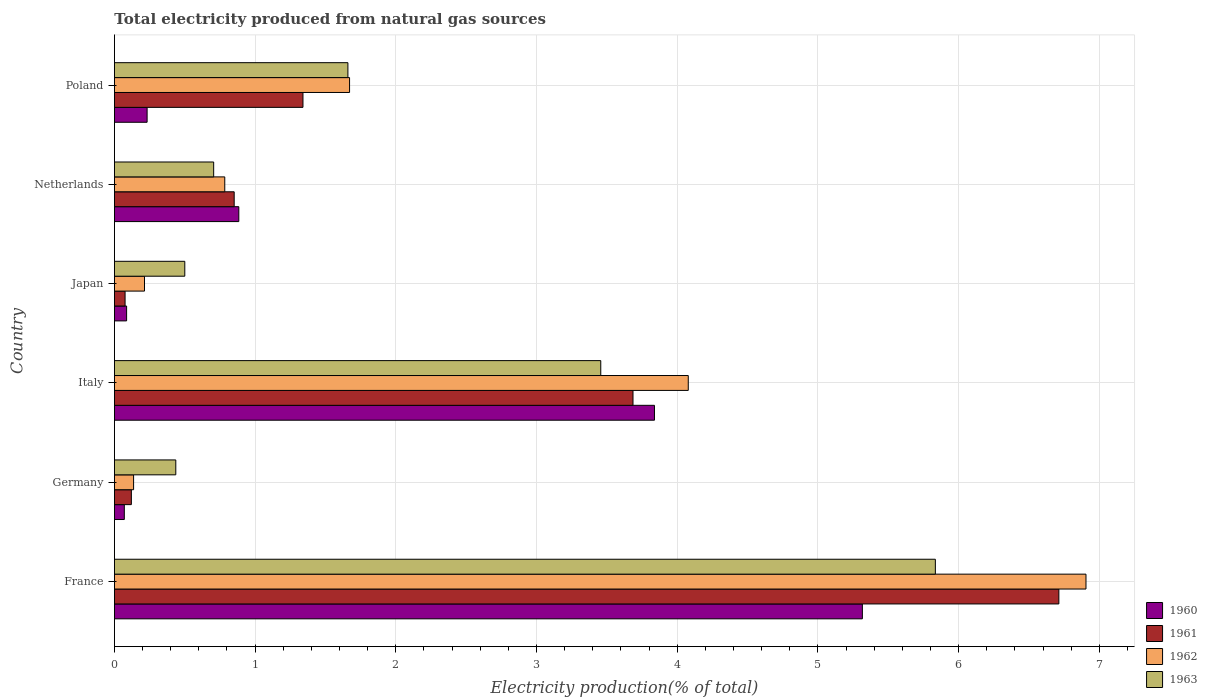How many groups of bars are there?
Offer a terse response. 6. Are the number of bars per tick equal to the number of legend labels?
Ensure brevity in your answer.  Yes. Are the number of bars on each tick of the Y-axis equal?
Make the answer very short. Yes. How many bars are there on the 2nd tick from the top?
Provide a short and direct response. 4. What is the total electricity produced in 1963 in Germany?
Offer a terse response. 0.44. Across all countries, what is the maximum total electricity produced in 1961?
Offer a terse response. 6.71. Across all countries, what is the minimum total electricity produced in 1961?
Offer a terse response. 0.08. In which country was the total electricity produced in 1962 minimum?
Your answer should be very brief. Germany. What is the total total electricity produced in 1963 in the graph?
Your answer should be compact. 12.59. What is the difference between the total electricity produced in 1962 in Italy and that in Netherlands?
Your answer should be compact. 3.29. What is the difference between the total electricity produced in 1963 in France and the total electricity produced in 1961 in Netherlands?
Provide a short and direct response. 4.98. What is the average total electricity produced in 1960 per country?
Your response must be concise. 1.74. What is the difference between the total electricity produced in 1963 and total electricity produced in 1962 in France?
Give a very brief answer. -1.07. In how many countries, is the total electricity produced in 1962 greater than 5.4 %?
Make the answer very short. 1. What is the ratio of the total electricity produced in 1961 in France to that in Poland?
Your response must be concise. 5.01. What is the difference between the highest and the second highest total electricity produced in 1963?
Provide a short and direct response. 2.38. What is the difference between the highest and the lowest total electricity produced in 1961?
Provide a short and direct response. 6.64. In how many countries, is the total electricity produced in 1961 greater than the average total electricity produced in 1961 taken over all countries?
Your answer should be very brief. 2. Is it the case that in every country, the sum of the total electricity produced in 1962 and total electricity produced in 1961 is greater than the total electricity produced in 1963?
Your response must be concise. No. Are all the bars in the graph horizontal?
Ensure brevity in your answer.  Yes. How many countries are there in the graph?
Provide a short and direct response. 6. Are the values on the major ticks of X-axis written in scientific E-notation?
Keep it short and to the point. No. Does the graph contain grids?
Keep it short and to the point. Yes. What is the title of the graph?
Offer a terse response. Total electricity produced from natural gas sources. What is the label or title of the X-axis?
Offer a terse response. Electricity production(% of total). What is the label or title of the Y-axis?
Make the answer very short. Country. What is the Electricity production(% of total) of 1960 in France?
Provide a succinct answer. 5.32. What is the Electricity production(% of total) of 1961 in France?
Your answer should be very brief. 6.71. What is the Electricity production(% of total) in 1962 in France?
Provide a short and direct response. 6.91. What is the Electricity production(% of total) in 1963 in France?
Your answer should be compact. 5.83. What is the Electricity production(% of total) in 1960 in Germany?
Ensure brevity in your answer.  0.07. What is the Electricity production(% of total) of 1961 in Germany?
Your response must be concise. 0.12. What is the Electricity production(% of total) in 1962 in Germany?
Your response must be concise. 0.14. What is the Electricity production(% of total) of 1963 in Germany?
Offer a very short reply. 0.44. What is the Electricity production(% of total) in 1960 in Italy?
Provide a succinct answer. 3.84. What is the Electricity production(% of total) in 1961 in Italy?
Offer a very short reply. 3.69. What is the Electricity production(% of total) in 1962 in Italy?
Offer a terse response. 4.08. What is the Electricity production(% of total) of 1963 in Italy?
Provide a short and direct response. 3.46. What is the Electricity production(% of total) of 1960 in Japan?
Provide a short and direct response. 0.09. What is the Electricity production(% of total) of 1961 in Japan?
Give a very brief answer. 0.08. What is the Electricity production(% of total) in 1962 in Japan?
Make the answer very short. 0.21. What is the Electricity production(% of total) in 1963 in Japan?
Provide a succinct answer. 0.5. What is the Electricity production(% of total) of 1960 in Netherlands?
Keep it short and to the point. 0.88. What is the Electricity production(% of total) of 1961 in Netherlands?
Ensure brevity in your answer.  0.85. What is the Electricity production(% of total) of 1962 in Netherlands?
Make the answer very short. 0.78. What is the Electricity production(% of total) in 1963 in Netherlands?
Your response must be concise. 0.71. What is the Electricity production(% of total) of 1960 in Poland?
Keep it short and to the point. 0.23. What is the Electricity production(% of total) of 1961 in Poland?
Keep it short and to the point. 1.34. What is the Electricity production(% of total) of 1962 in Poland?
Give a very brief answer. 1.67. What is the Electricity production(% of total) of 1963 in Poland?
Offer a terse response. 1.66. Across all countries, what is the maximum Electricity production(% of total) in 1960?
Offer a terse response. 5.32. Across all countries, what is the maximum Electricity production(% of total) in 1961?
Your answer should be compact. 6.71. Across all countries, what is the maximum Electricity production(% of total) in 1962?
Keep it short and to the point. 6.91. Across all countries, what is the maximum Electricity production(% of total) of 1963?
Offer a very short reply. 5.83. Across all countries, what is the minimum Electricity production(% of total) of 1960?
Your response must be concise. 0.07. Across all countries, what is the minimum Electricity production(% of total) of 1961?
Provide a succinct answer. 0.08. Across all countries, what is the minimum Electricity production(% of total) of 1962?
Ensure brevity in your answer.  0.14. Across all countries, what is the minimum Electricity production(% of total) of 1963?
Provide a short and direct response. 0.44. What is the total Electricity production(% of total) in 1960 in the graph?
Ensure brevity in your answer.  10.43. What is the total Electricity production(% of total) of 1961 in the graph?
Your response must be concise. 12.79. What is the total Electricity production(% of total) of 1962 in the graph?
Provide a short and direct response. 13.79. What is the total Electricity production(% of total) in 1963 in the graph?
Give a very brief answer. 12.59. What is the difference between the Electricity production(% of total) in 1960 in France and that in Germany?
Provide a succinct answer. 5.25. What is the difference between the Electricity production(% of total) in 1961 in France and that in Germany?
Your answer should be compact. 6.59. What is the difference between the Electricity production(% of total) of 1962 in France and that in Germany?
Offer a terse response. 6.77. What is the difference between the Electricity production(% of total) of 1963 in France and that in Germany?
Give a very brief answer. 5.4. What is the difference between the Electricity production(% of total) of 1960 in France and that in Italy?
Provide a short and direct response. 1.48. What is the difference between the Electricity production(% of total) in 1961 in France and that in Italy?
Make the answer very short. 3.03. What is the difference between the Electricity production(% of total) of 1962 in France and that in Italy?
Provide a short and direct response. 2.83. What is the difference between the Electricity production(% of total) of 1963 in France and that in Italy?
Your response must be concise. 2.38. What is the difference between the Electricity production(% of total) of 1960 in France and that in Japan?
Keep it short and to the point. 5.23. What is the difference between the Electricity production(% of total) of 1961 in France and that in Japan?
Your response must be concise. 6.64. What is the difference between the Electricity production(% of total) of 1962 in France and that in Japan?
Your answer should be compact. 6.69. What is the difference between the Electricity production(% of total) of 1963 in France and that in Japan?
Give a very brief answer. 5.33. What is the difference between the Electricity production(% of total) of 1960 in France and that in Netherlands?
Make the answer very short. 4.43. What is the difference between the Electricity production(% of total) of 1961 in France and that in Netherlands?
Ensure brevity in your answer.  5.86. What is the difference between the Electricity production(% of total) of 1962 in France and that in Netherlands?
Provide a succinct answer. 6.12. What is the difference between the Electricity production(% of total) of 1963 in France and that in Netherlands?
Provide a succinct answer. 5.13. What is the difference between the Electricity production(% of total) in 1960 in France and that in Poland?
Ensure brevity in your answer.  5.08. What is the difference between the Electricity production(% of total) in 1961 in France and that in Poland?
Offer a terse response. 5.37. What is the difference between the Electricity production(% of total) in 1962 in France and that in Poland?
Your response must be concise. 5.23. What is the difference between the Electricity production(% of total) in 1963 in France and that in Poland?
Your answer should be compact. 4.18. What is the difference between the Electricity production(% of total) in 1960 in Germany and that in Italy?
Provide a succinct answer. -3.77. What is the difference between the Electricity production(% of total) of 1961 in Germany and that in Italy?
Ensure brevity in your answer.  -3.57. What is the difference between the Electricity production(% of total) in 1962 in Germany and that in Italy?
Your response must be concise. -3.94. What is the difference between the Electricity production(% of total) in 1963 in Germany and that in Italy?
Your answer should be compact. -3.02. What is the difference between the Electricity production(% of total) of 1960 in Germany and that in Japan?
Ensure brevity in your answer.  -0.02. What is the difference between the Electricity production(% of total) in 1961 in Germany and that in Japan?
Your answer should be very brief. 0.04. What is the difference between the Electricity production(% of total) in 1962 in Germany and that in Japan?
Make the answer very short. -0.08. What is the difference between the Electricity production(% of total) of 1963 in Germany and that in Japan?
Ensure brevity in your answer.  -0.06. What is the difference between the Electricity production(% of total) of 1960 in Germany and that in Netherlands?
Your response must be concise. -0.81. What is the difference between the Electricity production(% of total) in 1961 in Germany and that in Netherlands?
Your answer should be very brief. -0.73. What is the difference between the Electricity production(% of total) in 1962 in Germany and that in Netherlands?
Ensure brevity in your answer.  -0.65. What is the difference between the Electricity production(% of total) of 1963 in Germany and that in Netherlands?
Your response must be concise. -0.27. What is the difference between the Electricity production(% of total) in 1960 in Germany and that in Poland?
Provide a succinct answer. -0.16. What is the difference between the Electricity production(% of total) in 1961 in Germany and that in Poland?
Provide a succinct answer. -1.22. What is the difference between the Electricity production(% of total) of 1962 in Germany and that in Poland?
Your response must be concise. -1.53. What is the difference between the Electricity production(% of total) of 1963 in Germany and that in Poland?
Your response must be concise. -1.22. What is the difference between the Electricity production(% of total) in 1960 in Italy and that in Japan?
Your answer should be compact. 3.75. What is the difference between the Electricity production(% of total) in 1961 in Italy and that in Japan?
Offer a terse response. 3.61. What is the difference between the Electricity production(% of total) in 1962 in Italy and that in Japan?
Provide a succinct answer. 3.86. What is the difference between the Electricity production(% of total) of 1963 in Italy and that in Japan?
Make the answer very short. 2.96. What is the difference between the Electricity production(% of total) of 1960 in Italy and that in Netherlands?
Your response must be concise. 2.95. What is the difference between the Electricity production(% of total) of 1961 in Italy and that in Netherlands?
Provide a succinct answer. 2.83. What is the difference between the Electricity production(% of total) of 1962 in Italy and that in Netherlands?
Ensure brevity in your answer.  3.29. What is the difference between the Electricity production(% of total) in 1963 in Italy and that in Netherlands?
Offer a very short reply. 2.75. What is the difference between the Electricity production(% of total) of 1960 in Italy and that in Poland?
Your answer should be very brief. 3.61. What is the difference between the Electricity production(% of total) in 1961 in Italy and that in Poland?
Make the answer very short. 2.35. What is the difference between the Electricity production(% of total) of 1962 in Italy and that in Poland?
Your answer should be compact. 2.41. What is the difference between the Electricity production(% of total) of 1963 in Italy and that in Poland?
Ensure brevity in your answer.  1.8. What is the difference between the Electricity production(% of total) of 1960 in Japan and that in Netherlands?
Provide a succinct answer. -0.8. What is the difference between the Electricity production(% of total) of 1961 in Japan and that in Netherlands?
Provide a succinct answer. -0.78. What is the difference between the Electricity production(% of total) of 1962 in Japan and that in Netherlands?
Your answer should be very brief. -0.57. What is the difference between the Electricity production(% of total) in 1963 in Japan and that in Netherlands?
Offer a very short reply. -0.21. What is the difference between the Electricity production(% of total) in 1960 in Japan and that in Poland?
Your response must be concise. -0.15. What is the difference between the Electricity production(% of total) in 1961 in Japan and that in Poland?
Your response must be concise. -1.26. What is the difference between the Electricity production(% of total) in 1962 in Japan and that in Poland?
Your answer should be compact. -1.46. What is the difference between the Electricity production(% of total) of 1963 in Japan and that in Poland?
Provide a short and direct response. -1.16. What is the difference between the Electricity production(% of total) in 1960 in Netherlands and that in Poland?
Keep it short and to the point. 0.65. What is the difference between the Electricity production(% of total) of 1961 in Netherlands and that in Poland?
Keep it short and to the point. -0.49. What is the difference between the Electricity production(% of total) of 1962 in Netherlands and that in Poland?
Your answer should be very brief. -0.89. What is the difference between the Electricity production(% of total) in 1963 in Netherlands and that in Poland?
Your response must be concise. -0.95. What is the difference between the Electricity production(% of total) in 1960 in France and the Electricity production(% of total) in 1961 in Germany?
Keep it short and to the point. 5.2. What is the difference between the Electricity production(% of total) of 1960 in France and the Electricity production(% of total) of 1962 in Germany?
Keep it short and to the point. 5.18. What is the difference between the Electricity production(% of total) in 1960 in France and the Electricity production(% of total) in 1963 in Germany?
Provide a succinct answer. 4.88. What is the difference between the Electricity production(% of total) of 1961 in France and the Electricity production(% of total) of 1962 in Germany?
Make the answer very short. 6.58. What is the difference between the Electricity production(% of total) of 1961 in France and the Electricity production(% of total) of 1963 in Germany?
Give a very brief answer. 6.28. What is the difference between the Electricity production(% of total) of 1962 in France and the Electricity production(% of total) of 1963 in Germany?
Provide a short and direct response. 6.47. What is the difference between the Electricity production(% of total) of 1960 in France and the Electricity production(% of total) of 1961 in Italy?
Your answer should be very brief. 1.63. What is the difference between the Electricity production(% of total) of 1960 in France and the Electricity production(% of total) of 1962 in Italy?
Provide a short and direct response. 1.24. What is the difference between the Electricity production(% of total) in 1960 in France and the Electricity production(% of total) in 1963 in Italy?
Your response must be concise. 1.86. What is the difference between the Electricity production(% of total) in 1961 in France and the Electricity production(% of total) in 1962 in Italy?
Offer a very short reply. 2.63. What is the difference between the Electricity production(% of total) of 1961 in France and the Electricity production(% of total) of 1963 in Italy?
Give a very brief answer. 3.26. What is the difference between the Electricity production(% of total) of 1962 in France and the Electricity production(% of total) of 1963 in Italy?
Your answer should be compact. 3.45. What is the difference between the Electricity production(% of total) of 1960 in France and the Electricity production(% of total) of 1961 in Japan?
Your answer should be compact. 5.24. What is the difference between the Electricity production(% of total) in 1960 in France and the Electricity production(% of total) in 1962 in Japan?
Make the answer very short. 5.1. What is the difference between the Electricity production(% of total) in 1960 in France and the Electricity production(% of total) in 1963 in Japan?
Your response must be concise. 4.82. What is the difference between the Electricity production(% of total) in 1961 in France and the Electricity production(% of total) in 1962 in Japan?
Keep it short and to the point. 6.5. What is the difference between the Electricity production(% of total) in 1961 in France and the Electricity production(% of total) in 1963 in Japan?
Your response must be concise. 6.21. What is the difference between the Electricity production(% of total) in 1962 in France and the Electricity production(% of total) in 1963 in Japan?
Your response must be concise. 6.4. What is the difference between the Electricity production(% of total) of 1960 in France and the Electricity production(% of total) of 1961 in Netherlands?
Ensure brevity in your answer.  4.46. What is the difference between the Electricity production(% of total) in 1960 in France and the Electricity production(% of total) in 1962 in Netherlands?
Provide a short and direct response. 4.53. What is the difference between the Electricity production(% of total) in 1960 in France and the Electricity production(% of total) in 1963 in Netherlands?
Give a very brief answer. 4.61. What is the difference between the Electricity production(% of total) in 1961 in France and the Electricity production(% of total) in 1962 in Netherlands?
Offer a terse response. 5.93. What is the difference between the Electricity production(% of total) of 1961 in France and the Electricity production(% of total) of 1963 in Netherlands?
Your answer should be very brief. 6.01. What is the difference between the Electricity production(% of total) in 1962 in France and the Electricity production(% of total) in 1963 in Netherlands?
Your response must be concise. 6.2. What is the difference between the Electricity production(% of total) of 1960 in France and the Electricity production(% of total) of 1961 in Poland?
Make the answer very short. 3.98. What is the difference between the Electricity production(% of total) in 1960 in France and the Electricity production(% of total) in 1962 in Poland?
Keep it short and to the point. 3.64. What is the difference between the Electricity production(% of total) in 1960 in France and the Electricity production(% of total) in 1963 in Poland?
Ensure brevity in your answer.  3.66. What is the difference between the Electricity production(% of total) of 1961 in France and the Electricity production(% of total) of 1962 in Poland?
Your answer should be compact. 5.04. What is the difference between the Electricity production(% of total) of 1961 in France and the Electricity production(% of total) of 1963 in Poland?
Keep it short and to the point. 5.05. What is the difference between the Electricity production(% of total) of 1962 in France and the Electricity production(% of total) of 1963 in Poland?
Your answer should be compact. 5.25. What is the difference between the Electricity production(% of total) in 1960 in Germany and the Electricity production(% of total) in 1961 in Italy?
Your response must be concise. -3.62. What is the difference between the Electricity production(% of total) of 1960 in Germany and the Electricity production(% of total) of 1962 in Italy?
Your answer should be compact. -4.01. What is the difference between the Electricity production(% of total) in 1960 in Germany and the Electricity production(% of total) in 1963 in Italy?
Your answer should be very brief. -3.39. What is the difference between the Electricity production(% of total) in 1961 in Germany and the Electricity production(% of total) in 1962 in Italy?
Your answer should be compact. -3.96. What is the difference between the Electricity production(% of total) of 1961 in Germany and the Electricity production(% of total) of 1963 in Italy?
Make the answer very short. -3.34. What is the difference between the Electricity production(% of total) in 1962 in Germany and the Electricity production(% of total) in 1963 in Italy?
Offer a terse response. -3.32. What is the difference between the Electricity production(% of total) in 1960 in Germany and the Electricity production(% of total) in 1961 in Japan?
Give a very brief answer. -0.01. What is the difference between the Electricity production(% of total) of 1960 in Germany and the Electricity production(% of total) of 1962 in Japan?
Offer a terse response. -0.14. What is the difference between the Electricity production(% of total) of 1960 in Germany and the Electricity production(% of total) of 1963 in Japan?
Keep it short and to the point. -0.43. What is the difference between the Electricity production(% of total) in 1961 in Germany and the Electricity production(% of total) in 1962 in Japan?
Keep it short and to the point. -0.09. What is the difference between the Electricity production(% of total) in 1961 in Germany and the Electricity production(% of total) in 1963 in Japan?
Your response must be concise. -0.38. What is the difference between the Electricity production(% of total) in 1962 in Germany and the Electricity production(% of total) in 1963 in Japan?
Your answer should be very brief. -0.36. What is the difference between the Electricity production(% of total) of 1960 in Germany and the Electricity production(% of total) of 1961 in Netherlands?
Your response must be concise. -0.78. What is the difference between the Electricity production(% of total) in 1960 in Germany and the Electricity production(% of total) in 1962 in Netherlands?
Offer a terse response. -0.71. What is the difference between the Electricity production(% of total) of 1960 in Germany and the Electricity production(% of total) of 1963 in Netherlands?
Keep it short and to the point. -0.64. What is the difference between the Electricity production(% of total) of 1961 in Germany and the Electricity production(% of total) of 1962 in Netherlands?
Keep it short and to the point. -0.66. What is the difference between the Electricity production(% of total) of 1961 in Germany and the Electricity production(% of total) of 1963 in Netherlands?
Ensure brevity in your answer.  -0.58. What is the difference between the Electricity production(% of total) of 1962 in Germany and the Electricity production(% of total) of 1963 in Netherlands?
Keep it short and to the point. -0.57. What is the difference between the Electricity production(% of total) of 1960 in Germany and the Electricity production(% of total) of 1961 in Poland?
Ensure brevity in your answer.  -1.27. What is the difference between the Electricity production(% of total) of 1960 in Germany and the Electricity production(% of total) of 1962 in Poland?
Your answer should be very brief. -1.6. What is the difference between the Electricity production(% of total) in 1960 in Germany and the Electricity production(% of total) in 1963 in Poland?
Offer a terse response. -1.59. What is the difference between the Electricity production(% of total) of 1961 in Germany and the Electricity production(% of total) of 1962 in Poland?
Ensure brevity in your answer.  -1.55. What is the difference between the Electricity production(% of total) of 1961 in Germany and the Electricity production(% of total) of 1963 in Poland?
Your answer should be compact. -1.54. What is the difference between the Electricity production(% of total) of 1962 in Germany and the Electricity production(% of total) of 1963 in Poland?
Offer a terse response. -1.52. What is the difference between the Electricity production(% of total) of 1960 in Italy and the Electricity production(% of total) of 1961 in Japan?
Make the answer very short. 3.76. What is the difference between the Electricity production(% of total) of 1960 in Italy and the Electricity production(% of total) of 1962 in Japan?
Your answer should be very brief. 3.62. What is the difference between the Electricity production(% of total) of 1960 in Italy and the Electricity production(% of total) of 1963 in Japan?
Offer a very short reply. 3.34. What is the difference between the Electricity production(% of total) in 1961 in Italy and the Electricity production(% of total) in 1962 in Japan?
Provide a succinct answer. 3.47. What is the difference between the Electricity production(% of total) in 1961 in Italy and the Electricity production(% of total) in 1963 in Japan?
Ensure brevity in your answer.  3.19. What is the difference between the Electricity production(% of total) of 1962 in Italy and the Electricity production(% of total) of 1963 in Japan?
Offer a very short reply. 3.58. What is the difference between the Electricity production(% of total) in 1960 in Italy and the Electricity production(% of total) in 1961 in Netherlands?
Keep it short and to the point. 2.99. What is the difference between the Electricity production(% of total) in 1960 in Italy and the Electricity production(% of total) in 1962 in Netherlands?
Ensure brevity in your answer.  3.05. What is the difference between the Electricity production(% of total) in 1960 in Italy and the Electricity production(% of total) in 1963 in Netherlands?
Your response must be concise. 3.13. What is the difference between the Electricity production(% of total) in 1961 in Italy and the Electricity production(% of total) in 1962 in Netherlands?
Give a very brief answer. 2.9. What is the difference between the Electricity production(% of total) in 1961 in Italy and the Electricity production(% of total) in 1963 in Netherlands?
Your answer should be very brief. 2.98. What is the difference between the Electricity production(% of total) in 1962 in Italy and the Electricity production(% of total) in 1963 in Netherlands?
Your answer should be compact. 3.37. What is the difference between the Electricity production(% of total) in 1960 in Italy and the Electricity production(% of total) in 1961 in Poland?
Your answer should be very brief. 2.5. What is the difference between the Electricity production(% of total) in 1960 in Italy and the Electricity production(% of total) in 1962 in Poland?
Make the answer very short. 2.17. What is the difference between the Electricity production(% of total) of 1960 in Italy and the Electricity production(% of total) of 1963 in Poland?
Offer a terse response. 2.18. What is the difference between the Electricity production(% of total) of 1961 in Italy and the Electricity production(% of total) of 1962 in Poland?
Offer a terse response. 2.01. What is the difference between the Electricity production(% of total) of 1961 in Italy and the Electricity production(% of total) of 1963 in Poland?
Your answer should be compact. 2.03. What is the difference between the Electricity production(% of total) of 1962 in Italy and the Electricity production(% of total) of 1963 in Poland?
Your answer should be compact. 2.42. What is the difference between the Electricity production(% of total) of 1960 in Japan and the Electricity production(% of total) of 1961 in Netherlands?
Keep it short and to the point. -0.76. What is the difference between the Electricity production(% of total) of 1960 in Japan and the Electricity production(% of total) of 1962 in Netherlands?
Your answer should be compact. -0.7. What is the difference between the Electricity production(% of total) in 1960 in Japan and the Electricity production(% of total) in 1963 in Netherlands?
Provide a succinct answer. -0.62. What is the difference between the Electricity production(% of total) of 1961 in Japan and the Electricity production(% of total) of 1962 in Netherlands?
Ensure brevity in your answer.  -0.71. What is the difference between the Electricity production(% of total) in 1961 in Japan and the Electricity production(% of total) in 1963 in Netherlands?
Offer a very short reply. -0.63. What is the difference between the Electricity production(% of total) of 1962 in Japan and the Electricity production(% of total) of 1963 in Netherlands?
Give a very brief answer. -0.49. What is the difference between the Electricity production(% of total) in 1960 in Japan and the Electricity production(% of total) in 1961 in Poland?
Your answer should be very brief. -1.25. What is the difference between the Electricity production(% of total) of 1960 in Japan and the Electricity production(% of total) of 1962 in Poland?
Your response must be concise. -1.58. What is the difference between the Electricity production(% of total) of 1960 in Japan and the Electricity production(% of total) of 1963 in Poland?
Provide a succinct answer. -1.57. What is the difference between the Electricity production(% of total) in 1961 in Japan and the Electricity production(% of total) in 1962 in Poland?
Make the answer very short. -1.6. What is the difference between the Electricity production(% of total) in 1961 in Japan and the Electricity production(% of total) in 1963 in Poland?
Provide a short and direct response. -1.58. What is the difference between the Electricity production(% of total) in 1962 in Japan and the Electricity production(% of total) in 1963 in Poland?
Your response must be concise. -1.45. What is the difference between the Electricity production(% of total) in 1960 in Netherlands and the Electricity production(% of total) in 1961 in Poland?
Your answer should be compact. -0.46. What is the difference between the Electricity production(% of total) in 1960 in Netherlands and the Electricity production(% of total) in 1962 in Poland?
Offer a very short reply. -0.79. What is the difference between the Electricity production(% of total) in 1960 in Netherlands and the Electricity production(% of total) in 1963 in Poland?
Your response must be concise. -0.78. What is the difference between the Electricity production(% of total) of 1961 in Netherlands and the Electricity production(% of total) of 1962 in Poland?
Offer a very short reply. -0.82. What is the difference between the Electricity production(% of total) in 1961 in Netherlands and the Electricity production(% of total) in 1963 in Poland?
Your answer should be very brief. -0.81. What is the difference between the Electricity production(% of total) in 1962 in Netherlands and the Electricity production(% of total) in 1963 in Poland?
Offer a terse response. -0.88. What is the average Electricity production(% of total) of 1960 per country?
Offer a terse response. 1.74. What is the average Electricity production(% of total) in 1961 per country?
Your response must be concise. 2.13. What is the average Electricity production(% of total) of 1962 per country?
Ensure brevity in your answer.  2.3. What is the average Electricity production(% of total) in 1963 per country?
Offer a terse response. 2.1. What is the difference between the Electricity production(% of total) in 1960 and Electricity production(% of total) in 1961 in France?
Offer a terse response. -1.4. What is the difference between the Electricity production(% of total) in 1960 and Electricity production(% of total) in 1962 in France?
Your response must be concise. -1.59. What is the difference between the Electricity production(% of total) of 1960 and Electricity production(% of total) of 1963 in France?
Make the answer very short. -0.52. What is the difference between the Electricity production(% of total) of 1961 and Electricity production(% of total) of 1962 in France?
Offer a very short reply. -0.19. What is the difference between the Electricity production(% of total) of 1961 and Electricity production(% of total) of 1963 in France?
Provide a succinct answer. 0.88. What is the difference between the Electricity production(% of total) in 1962 and Electricity production(% of total) in 1963 in France?
Give a very brief answer. 1.07. What is the difference between the Electricity production(% of total) of 1960 and Electricity production(% of total) of 1962 in Germany?
Keep it short and to the point. -0.07. What is the difference between the Electricity production(% of total) of 1960 and Electricity production(% of total) of 1963 in Germany?
Your answer should be compact. -0.37. What is the difference between the Electricity production(% of total) in 1961 and Electricity production(% of total) in 1962 in Germany?
Your answer should be very brief. -0.02. What is the difference between the Electricity production(% of total) of 1961 and Electricity production(% of total) of 1963 in Germany?
Your answer should be very brief. -0.32. What is the difference between the Electricity production(% of total) in 1962 and Electricity production(% of total) in 1963 in Germany?
Your response must be concise. -0.3. What is the difference between the Electricity production(% of total) of 1960 and Electricity production(% of total) of 1961 in Italy?
Make the answer very short. 0.15. What is the difference between the Electricity production(% of total) of 1960 and Electricity production(% of total) of 1962 in Italy?
Ensure brevity in your answer.  -0.24. What is the difference between the Electricity production(% of total) of 1960 and Electricity production(% of total) of 1963 in Italy?
Your response must be concise. 0.38. What is the difference between the Electricity production(% of total) of 1961 and Electricity production(% of total) of 1962 in Italy?
Keep it short and to the point. -0.39. What is the difference between the Electricity production(% of total) of 1961 and Electricity production(% of total) of 1963 in Italy?
Provide a short and direct response. 0.23. What is the difference between the Electricity production(% of total) in 1962 and Electricity production(% of total) in 1963 in Italy?
Your response must be concise. 0.62. What is the difference between the Electricity production(% of total) in 1960 and Electricity production(% of total) in 1961 in Japan?
Provide a short and direct response. 0.01. What is the difference between the Electricity production(% of total) of 1960 and Electricity production(% of total) of 1962 in Japan?
Your response must be concise. -0.13. What is the difference between the Electricity production(% of total) of 1960 and Electricity production(% of total) of 1963 in Japan?
Your answer should be compact. -0.41. What is the difference between the Electricity production(% of total) in 1961 and Electricity production(% of total) in 1962 in Japan?
Give a very brief answer. -0.14. What is the difference between the Electricity production(% of total) in 1961 and Electricity production(% of total) in 1963 in Japan?
Offer a terse response. -0.42. What is the difference between the Electricity production(% of total) of 1962 and Electricity production(% of total) of 1963 in Japan?
Keep it short and to the point. -0.29. What is the difference between the Electricity production(% of total) in 1960 and Electricity production(% of total) in 1961 in Netherlands?
Provide a short and direct response. 0.03. What is the difference between the Electricity production(% of total) of 1960 and Electricity production(% of total) of 1962 in Netherlands?
Offer a very short reply. 0.1. What is the difference between the Electricity production(% of total) in 1960 and Electricity production(% of total) in 1963 in Netherlands?
Your answer should be compact. 0.18. What is the difference between the Electricity production(% of total) in 1961 and Electricity production(% of total) in 1962 in Netherlands?
Provide a succinct answer. 0.07. What is the difference between the Electricity production(% of total) of 1961 and Electricity production(% of total) of 1963 in Netherlands?
Your answer should be very brief. 0.15. What is the difference between the Electricity production(% of total) in 1962 and Electricity production(% of total) in 1963 in Netherlands?
Your answer should be very brief. 0.08. What is the difference between the Electricity production(% of total) of 1960 and Electricity production(% of total) of 1961 in Poland?
Your answer should be compact. -1.11. What is the difference between the Electricity production(% of total) of 1960 and Electricity production(% of total) of 1962 in Poland?
Your answer should be compact. -1.44. What is the difference between the Electricity production(% of total) of 1960 and Electricity production(% of total) of 1963 in Poland?
Your response must be concise. -1.43. What is the difference between the Electricity production(% of total) of 1961 and Electricity production(% of total) of 1962 in Poland?
Provide a short and direct response. -0.33. What is the difference between the Electricity production(% of total) in 1961 and Electricity production(% of total) in 1963 in Poland?
Offer a very short reply. -0.32. What is the difference between the Electricity production(% of total) of 1962 and Electricity production(% of total) of 1963 in Poland?
Offer a terse response. 0.01. What is the ratio of the Electricity production(% of total) of 1960 in France to that in Germany?
Make the answer very short. 75.62. What is the ratio of the Electricity production(% of total) of 1961 in France to that in Germany?
Keep it short and to the point. 55.79. What is the ratio of the Electricity production(% of total) in 1962 in France to that in Germany?
Provide a succinct answer. 50.69. What is the ratio of the Electricity production(% of total) in 1963 in France to that in Germany?
Your answer should be compact. 13.38. What is the ratio of the Electricity production(% of total) in 1960 in France to that in Italy?
Provide a succinct answer. 1.39. What is the ratio of the Electricity production(% of total) of 1961 in France to that in Italy?
Provide a succinct answer. 1.82. What is the ratio of the Electricity production(% of total) of 1962 in France to that in Italy?
Your response must be concise. 1.69. What is the ratio of the Electricity production(% of total) of 1963 in France to that in Italy?
Provide a short and direct response. 1.69. What is the ratio of the Electricity production(% of total) in 1960 in France to that in Japan?
Your answer should be very brief. 61.4. What is the ratio of the Electricity production(% of total) in 1961 in France to that in Japan?
Offer a very short reply. 88.67. What is the ratio of the Electricity production(% of total) of 1962 in France to that in Japan?
Give a very brief answer. 32.32. What is the ratio of the Electricity production(% of total) of 1963 in France to that in Japan?
Keep it short and to the point. 11.67. What is the ratio of the Electricity production(% of total) in 1960 in France to that in Netherlands?
Offer a terse response. 6.01. What is the ratio of the Electricity production(% of total) of 1961 in France to that in Netherlands?
Offer a very short reply. 7.89. What is the ratio of the Electricity production(% of total) in 1962 in France to that in Netherlands?
Give a very brief answer. 8.8. What is the ratio of the Electricity production(% of total) in 1963 in France to that in Netherlands?
Your answer should be very brief. 8.27. What is the ratio of the Electricity production(% of total) in 1960 in France to that in Poland?
Make the answer very short. 22.89. What is the ratio of the Electricity production(% of total) in 1961 in France to that in Poland?
Your response must be concise. 5.01. What is the ratio of the Electricity production(% of total) in 1962 in France to that in Poland?
Your answer should be very brief. 4.13. What is the ratio of the Electricity production(% of total) of 1963 in France to that in Poland?
Your answer should be compact. 3.52. What is the ratio of the Electricity production(% of total) in 1960 in Germany to that in Italy?
Offer a terse response. 0.02. What is the ratio of the Electricity production(% of total) of 1961 in Germany to that in Italy?
Offer a terse response. 0.03. What is the ratio of the Electricity production(% of total) in 1962 in Germany to that in Italy?
Provide a short and direct response. 0.03. What is the ratio of the Electricity production(% of total) of 1963 in Germany to that in Italy?
Provide a short and direct response. 0.13. What is the ratio of the Electricity production(% of total) in 1960 in Germany to that in Japan?
Make the answer very short. 0.81. What is the ratio of the Electricity production(% of total) in 1961 in Germany to that in Japan?
Offer a very short reply. 1.59. What is the ratio of the Electricity production(% of total) of 1962 in Germany to that in Japan?
Your response must be concise. 0.64. What is the ratio of the Electricity production(% of total) of 1963 in Germany to that in Japan?
Keep it short and to the point. 0.87. What is the ratio of the Electricity production(% of total) in 1960 in Germany to that in Netherlands?
Offer a very short reply. 0.08. What is the ratio of the Electricity production(% of total) in 1961 in Germany to that in Netherlands?
Your answer should be compact. 0.14. What is the ratio of the Electricity production(% of total) of 1962 in Germany to that in Netherlands?
Your answer should be very brief. 0.17. What is the ratio of the Electricity production(% of total) in 1963 in Germany to that in Netherlands?
Your answer should be compact. 0.62. What is the ratio of the Electricity production(% of total) in 1960 in Germany to that in Poland?
Offer a terse response. 0.3. What is the ratio of the Electricity production(% of total) of 1961 in Germany to that in Poland?
Offer a very short reply. 0.09. What is the ratio of the Electricity production(% of total) of 1962 in Germany to that in Poland?
Provide a short and direct response. 0.08. What is the ratio of the Electricity production(% of total) of 1963 in Germany to that in Poland?
Your answer should be very brief. 0.26. What is the ratio of the Electricity production(% of total) in 1960 in Italy to that in Japan?
Keep it short and to the point. 44.33. What is the ratio of the Electricity production(% of total) of 1961 in Italy to that in Japan?
Provide a short and direct response. 48.69. What is the ratio of the Electricity production(% of total) in 1962 in Italy to that in Japan?
Keep it short and to the point. 19.09. What is the ratio of the Electricity production(% of total) in 1963 in Italy to that in Japan?
Your answer should be compact. 6.91. What is the ratio of the Electricity production(% of total) in 1960 in Italy to that in Netherlands?
Provide a short and direct response. 4.34. What is the ratio of the Electricity production(% of total) of 1961 in Italy to that in Netherlands?
Keep it short and to the point. 4.33. What is the ratio of the Electricity production(% of total) in 1962 in Italy to that in Netherlands?
Offer a very short reply. 5.2. What is the ratio of the Electricity production(% of total) of 1963 in Italy to that in Netherlands?
Make the answer very short. 4.9. What is the ratio of the Electricity production(% of total) in 1960 in Italy to that in Poland?
Offer a terse response. 16.53. What is the ratio of the Electricity production(% of total) in 1961 in Italy to that in Poland?
Give a very brief answer. 2.75. What is the ratio of the Electricity production(% of total) in 1962 in Italy to that in Poland?
Give a very brief answer. 2.44. What is the ratio of the Electricity production(% of total) in 1963 in Italy to that in Poland?
Offer a very short reply. 2.08. What is the ratio of the Electricity production(% of total) in 1960 in Japan to that in Netherlands?
Your response must be concise. 0.1. What is the ratio of the Electricity production(% of total) of 1961 in Japan to that in Netherlands?
Your answer should be very brief. 0.09. What is the ratio of the Electricity production(% of total) in 1962 in Japan to that in Netherlands?
Your answer should be very brief. 0.27. What is the ratio of the Electricity production(% of total) of 1963 in Japan to that in Netherlands?
Your response must be concise. 0.71. What is the ratio of the Electricity production(% of total) in 1960 in Japan to that in Poland?
Your answer should be very brief. 0.37. What is the ratio of the Electricity production(% of total) in 1961 in Japan to that in Poland?
Your answer should be very brief. 0.06. What is the ratio of the Electricity production(% of total) in 1962 in Japan to that in Poland?
Keep it short and to the point. 0.13. What is the ratio of the Electricity production(% of total) in 1963 in Japan to that in Poland?
Your response must be concise. 0.3. What is the ratio of the Electricity production(% of total) of 1960 in Netherlands to that in Poland?
Make the answer very short. 3.81. What is the ratio of the Electricity production(% of total) of 1961 in Netherlands to that in Poland?
Keep it short and to the point. 0.64. What is the ratio of the Electricity production(% of total) of 1962 in Netherlands to that in Poland?
Keep it short and to the point. 0.47. What is the ratio of the Electricity production(% of total) in 1963 in Netherlands to that in Poland?
Provide a short and direct response. 0.42. What is the difference between the highest and the second highest Electricity production(% of total) in 1960?
Provide a short and direct response. 1.48. What is the difference between the highest and the second highest Electricity production(% of total) in 1961?
Your answer should be compact. 3.03. What is the difference between the highest and the second highest Electricity production(% of total) in 1962?
Your response must be concise. 2.83. What is the difference between the highest and the second highest Electricity production(% of total) in 1963?
Your answer should be compact. 2.38. What is the difference between the highest and the lowest Electricity production(% of total) of 1960?
Offer a very short reply. 5.25. What is the difference between the highest and the lowest Electricity production(% of total) of 1961?
Your answer should be compact. 6.64. What is the difference between the highest and the lowest Electricity production(% of total) of 1962?
Your answer should be compact. 6.77. What is the difference between the highest and the lowest Electricity production(% of total) of 1963?
Your answer should be compact. 5.4. 